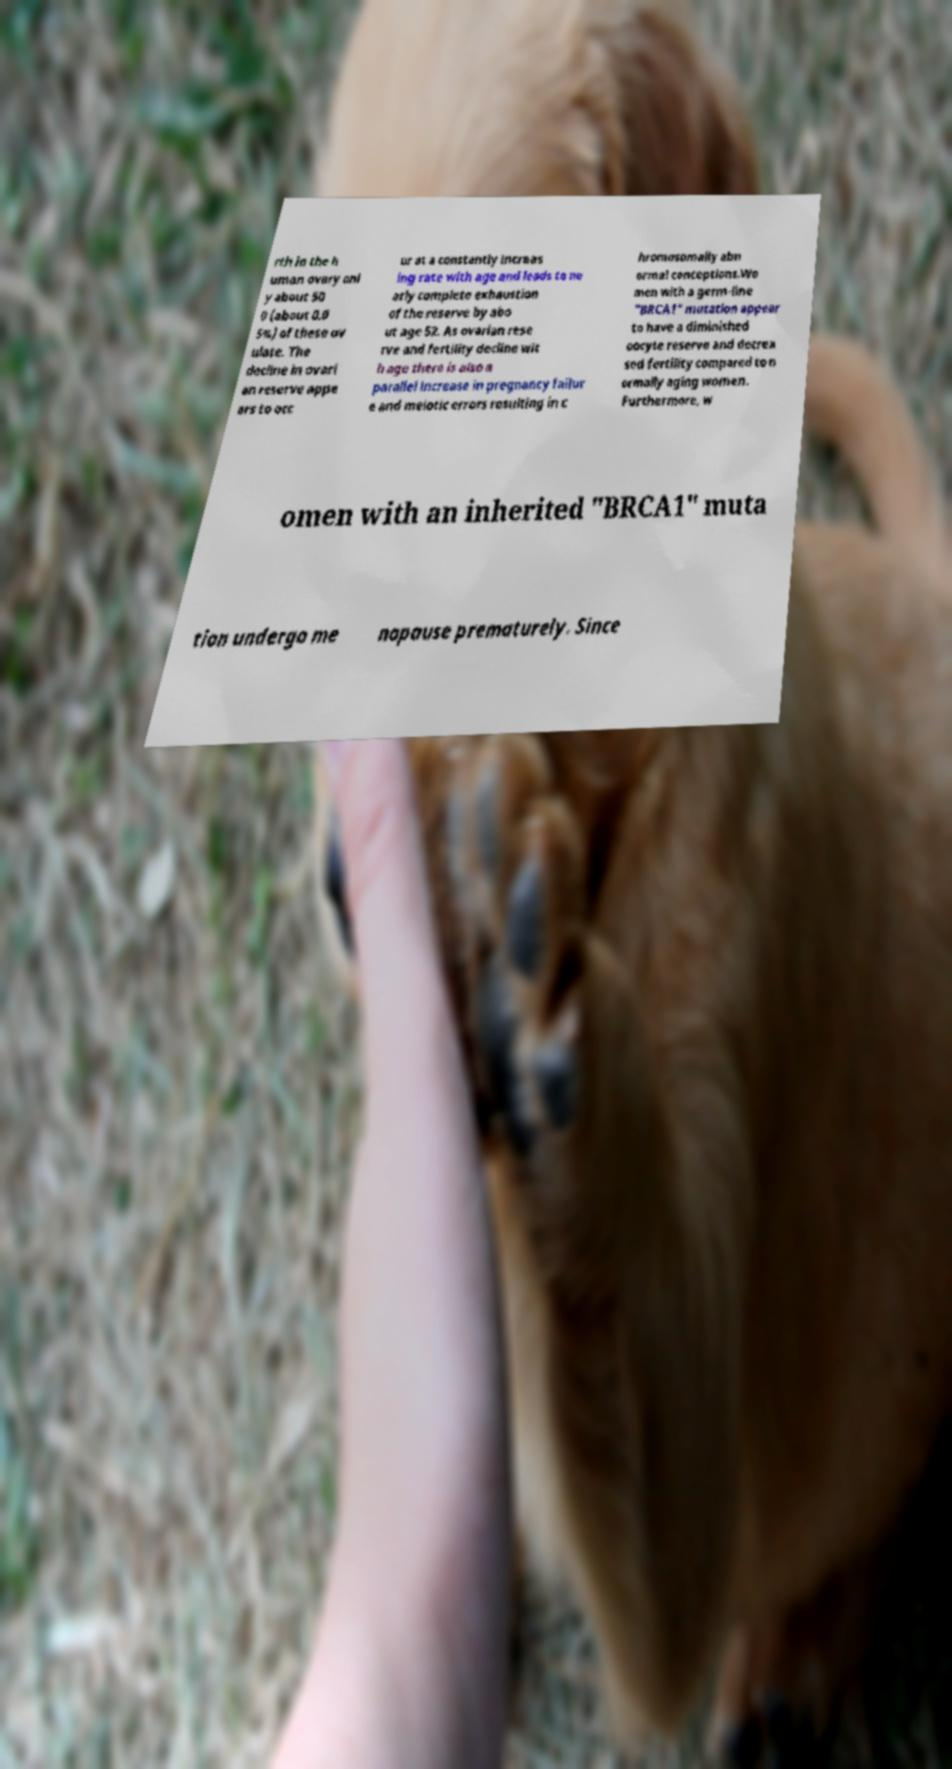Could you extract and type out the text from this image? rth in the h uman ovary onl y about 50 0 (about 0.0 5%) of these ov ulate. The decline in ovari an reserve appe ars to occ ur at a constantly increas ing rate with age and leads to ne arly complete exhaustion of the reserve by abo ut age 52. As ovarian rese rve and fertility decline wit h age there is also a parallel increase in pregnancy failur e and meiotic errors resulting in c hromosomally abn ormal conceptions.Wo men with a germ-line "BRCA1" mutation appear to have a diminished oocyte reserve and decrea sed fertility compared to n ormally aging women. Furthermore, w omen with an inherited "BRCA1" muta tion undergo me nopause prematurely. Since 